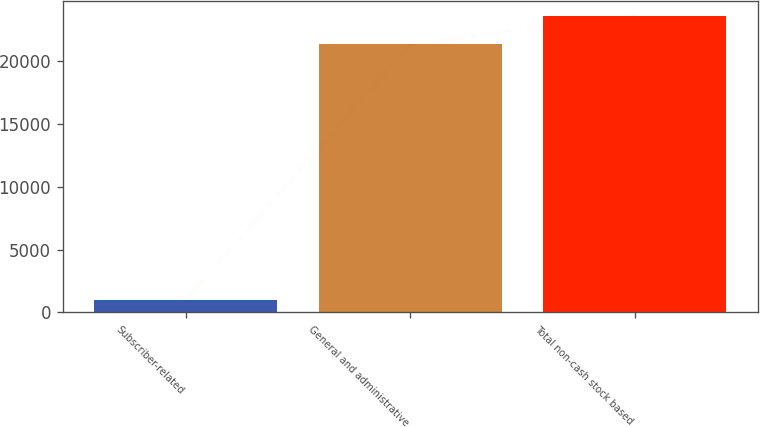Convert chart. <chart><loc_0><loc_0><loc_500><loc_500><bar_chart><fcel>Subscriber-related<fcel>General and administrative<fcel>Total non-cash stock based<nl><fcel>967<fcel>21404<fcel>23608.9<nl></chart> 